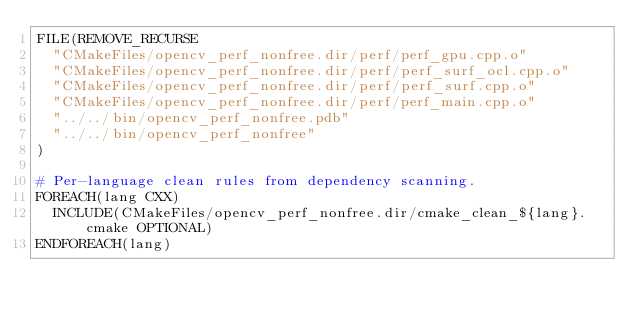<code> <loc_0><loc_0><loc_500><loc_500><_CMake_>FILE(REMOVE_RECURSE
  "CMakeFiles/opencv_perf_nonfree.dir/perf/perf_gpu.cpp.o"
  "CMakeFiles/opencv_perf_nonfree.dir/perf/perf_surf_ocl.cpp.o"
  "CMakeFiles/opencv_perf_nonfree.dir/perf/perf_surf.cpp.o"
  "CMakeFiles/opencv_perf_nonfree.dir/perf/perf_main.cpp.o"
  "../../bin/opencv_perf_nonfree.pdb"
  "../../bin/opencv_perf_nonfree"
)

# Per-language clean rules from dependency scanning.
FOREACH(lang CXX)
  INCLUDE(CMakeFiles/opencv_perf_nonfree.dir/cmake_clean_${lang}.cmake OPTIONAL)
ENDFOREACH(lang)
</code> 